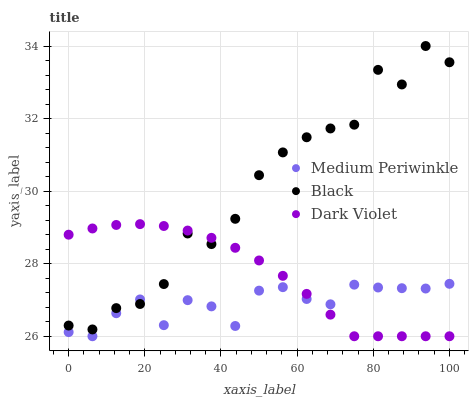Does Medium Periwinkle have the minimum area under the curve?
Answer yes or no. Yes. Does Black have the maximum area under the curve?
Answer yes or no. Yes. Does Dark Violet have the minimum area under the curve?
Answer yes or no. No. Does Dark Violet have the maximum area under the curve?
Answer yes or no. No. Is Dark Violet the smoothest?
Answer yes or no. Yes. Is Black the roughest?
Answer yes or no. Yes. Is Medium Periwinkle the smoothest?
Answer yes or no. No. Is Medium Periwinkle the roughest?
Answer yes or no. No. Does Medium Periwinkle have the lowest value?
Answer yes or no. Yes. Does Black have the highest value?
Answer yes or no. Yes. Does Dark Violet have the highest value?
Answer yes or no. No. Does Black intersect Dark Violet?
Answer yes or no. Yes. Is Black less than Dark Violet?
Answer yes or no. No. Is Black greater than Dark Violet?
Answer yes or no. No. 